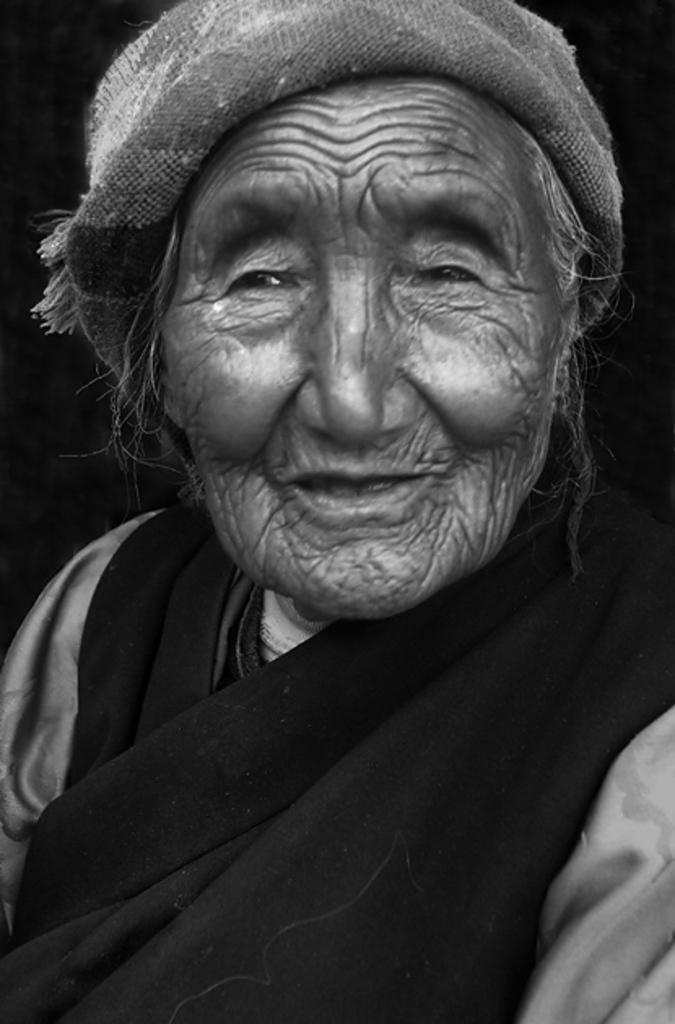How would you summarize this image in a sentence or two? In this picture we can see a old woman. 